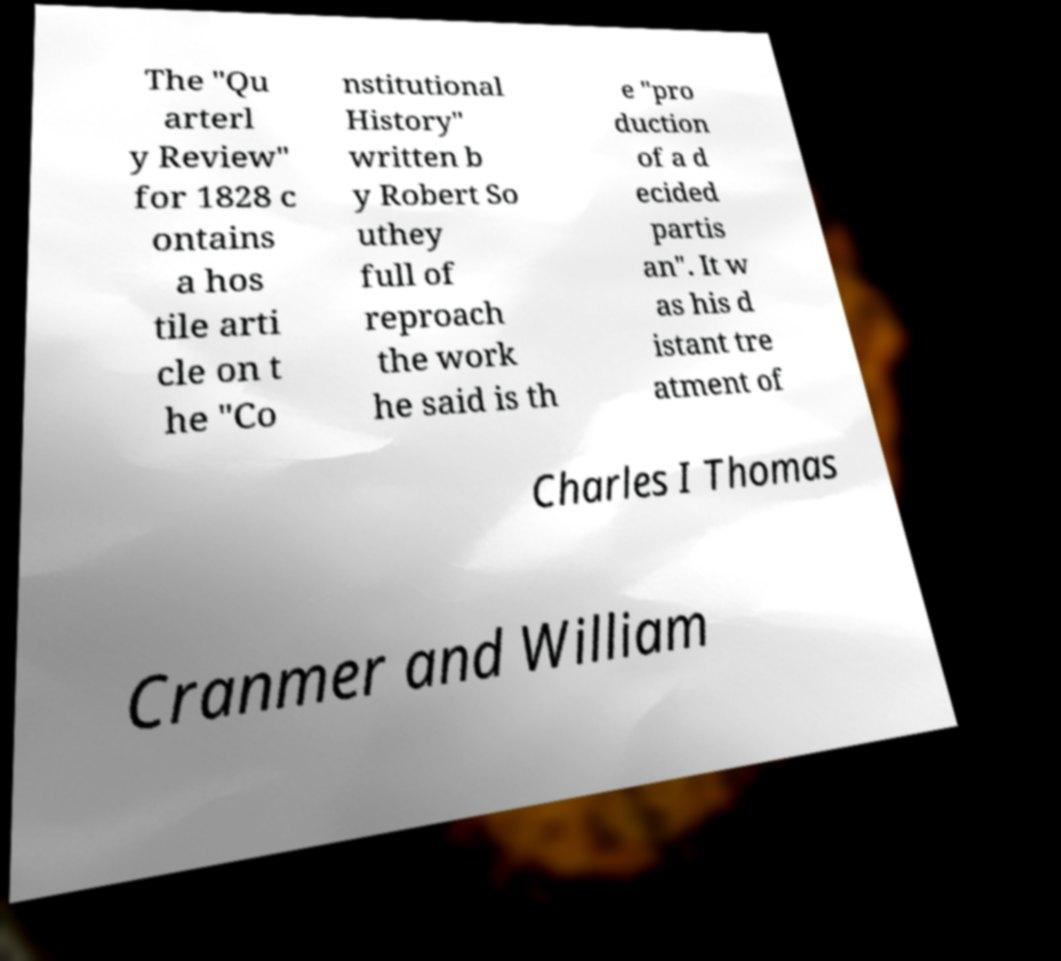I need the written content from this picture converted into text. Can you do that? The "Qu arterl y Review" for 1828 c ontains a hos tile arti cle on t he "Co nstitutional History" written b y Robert So uthey full of reproach the work he said is th e "pro duction of a d ecided partis an". It w as his d istant tre atment of Charles I Thomas Cranmer and William 